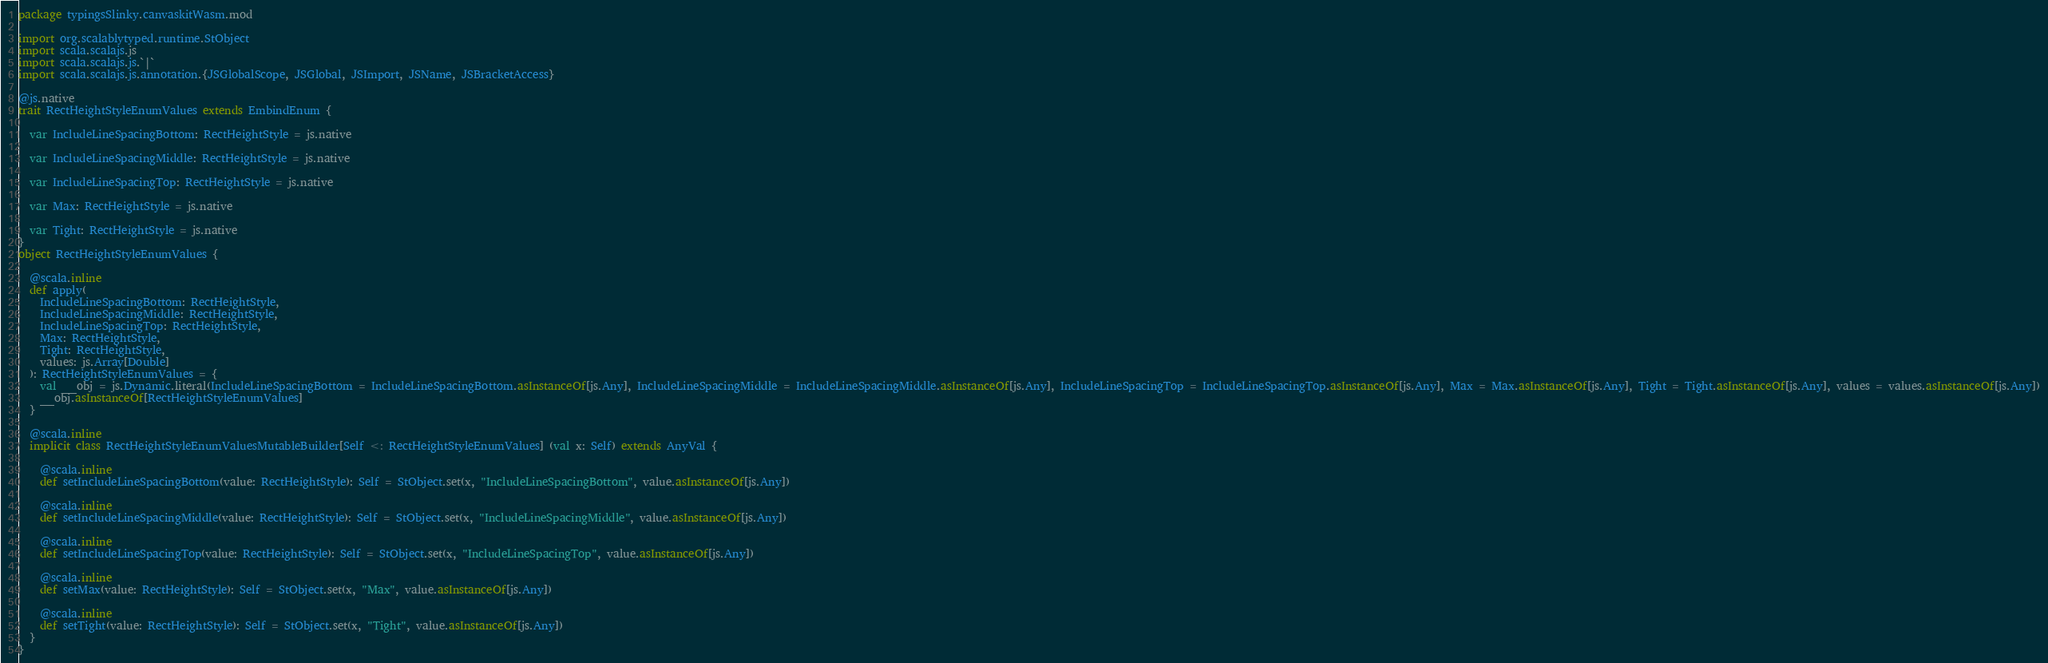<code> <loc_0><loc_0><loc_500><loc_500><_Scala_>package typingsSlinky.canvaskitWasm.mod

import org.scalablytyped.runtime.StObject
import scala.scalajs.js
import scala.scalajs.js.`|`
import scala.scalajs.js.annotation.{JSGlobalScope, JSGlobal, JSImport, JSName, JSBracketAccess}

@js.native
trait RectHeightStyleEnumValues extends EmbindEnum {
  
  var IncludeLineSpacingBottom: RectHeightStyle = js.native
  
  var IncludeLineSpacingMiddle: RectHeightStyle = js.native
  
  var IncludeLineSpacingTop: RectHeightStyle = js.native
  
  var Max: RectHeightStyle = js.native
  
  var Tight: RectHeightStyle = js.native
}
object RectHeightStyleEnumValues {
  
  @scala.inline
  def apply(
    IncludeLineSpacingBottom: RectHeightStyle,
    IncludeLineSpacingMiddle: RectHeightStyle,
    IncludeLineSpacingTop: RectHeightStyle,
    Max: RectHeightStyle,
    Tight: RectHeightStyle,
    values: js.Array[Double]
  ): RectHeightStyleEnumValues = {
    val __obj = js.Dynamic.literal(IncludeLineSpacingBottom = IncludeLineSpacingBottom.asInstanceOf[js.Any], IncludeLineSpacingMiddle = IncludeLineSpacingMiddle.asInstanceOf[js.Any], IncludeLineSpacingTop = IncludeLineSpacingTop.asInstanceOf[js.Any], Max = Max.asInstanceOf[js.Any], Tight = Tight.asInstanceOf[js.Any], values = values.asInstanceOf[js.Any])
    __obj.asInstanceOf[RectHeightStyleEnumValues]
  }
  
  @scala.inline
  implicit class RectHeightStyleEnumValuesMutableBuilder[Self <: RectHeightStyleEnumValues] (val x: Self) extends AnyVal {
    
    @scala.inline
    def setIncludeLineSpacingBottom(value: RectHeightStyle): Self = StObject.set(x, "IncludeLineSpacingBottom", value.asInstanceOf[js.Any])
    
    @scala.inline
    def setIncludeLineSpacingMiddle(value: RectHeightStyle): Self = StObject.set(x, "IncludeLineSpacingMiddle", value.asInstanceOf[js.Any])
    
    @scala.inline
    def setIncludeLineSpacingTop(value: RectHeightStyle): Self = StObject.set(x, "IncludeLineSpacingTop", value.asInstanceOf[js.Any])
    
    @scala.inline
    def setMax(value: RectHeightStyle): Self = StObject.set(x, "Max", value.asInstanceOf[js.Any])
    
    @scala.inline
    def setTight(value: RectHeightStyle): Self = StObject.set(x, "Tight", value.asInstanceOf[js.Any])
  }
}
</code> 